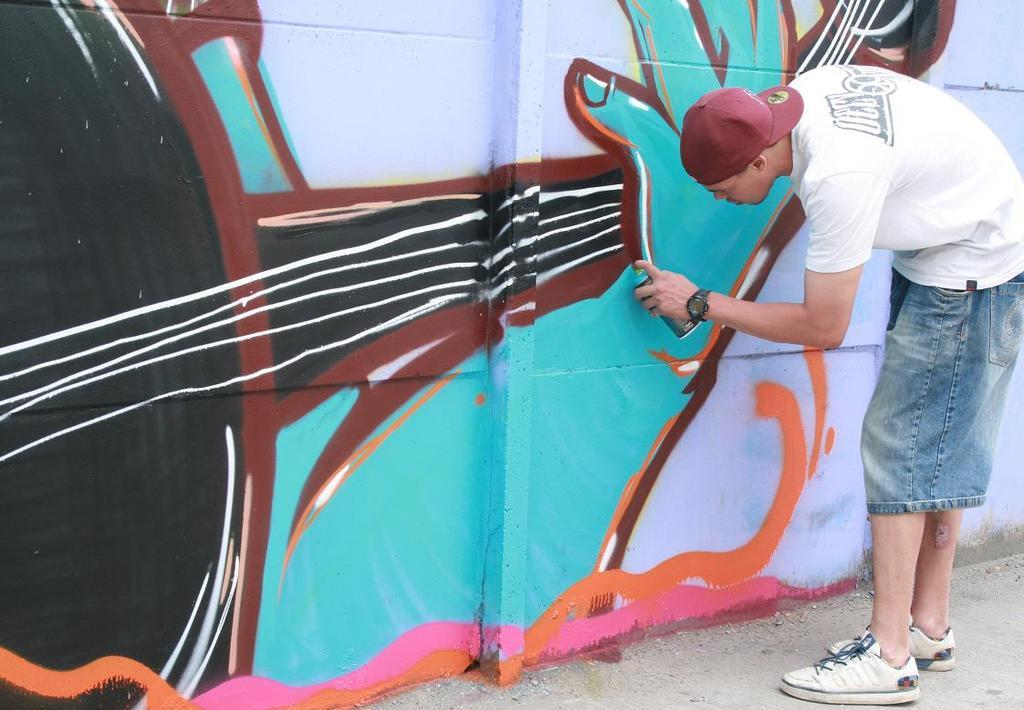What is the main subject of the image? There is a person standing in the image. What can be seen on the wall in the image? There is graffiti of a bottle on a wall in the image. What type of crayon is the person using to draw the graffiti in the image? There is no crayon present in the image, and the person is not drawing anything in the image. What is the profit margin of the graffiti artist in the image? There is no indication of any financial transactions or profit margins in the image. 